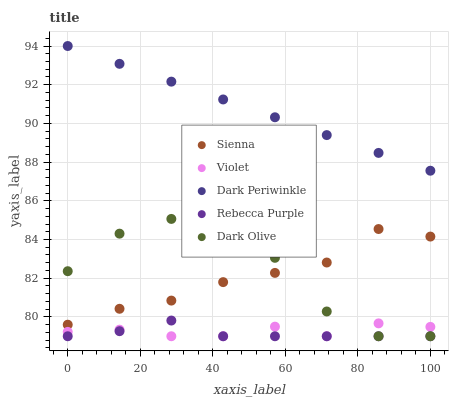Does Rebecca Purple have the minimum area under the curve?
Answer yes or no. Yes. Does Dark Periwinkle have the maximum area under the curve?
Answer yes or no. Yes. Does Dark Olive have the minimum area under the curve?
Answer yes or no. No. Does Dark Olive have the maximum area under the curve?
Answer yes or no. No. Is Dark Periwinkle the smoothest?
Answer yes or no. Yes. Is Dark Olive the roughest?
Answer yes or no. Yes. Is Dark Olive the smoothest?
Answer yes or no. No. Is Dark Periwinkle the roughest?
Answer yes or no. No. Does Dark Olive have the lowest value?
Answer yes or no. Yes. Does Dark Periwinkle have the lowest value?
Answer yes or no. No. Does Dark Periwinkle have the highest value?
Answer yes or no. Yes. Does Dark Olive have the highest value?
Answer yes or no. No. Is Sienna less than Dark Periwinkle?
Answer yes or no. Yes. Is Dark Periwinkle greater than Rebecca Purple?
Answer yes or no. Yes. Does Dark Olive intersect Sienna?
Answer yes or no. Yes. Is Dark Olive less than Sienna?
Answer yes or no. No. Is Dark Olive greater than Sienna?
Answer yes or no. No. Does Sienna intersect Dark Periwinkle?
Answer yes or no. No. 